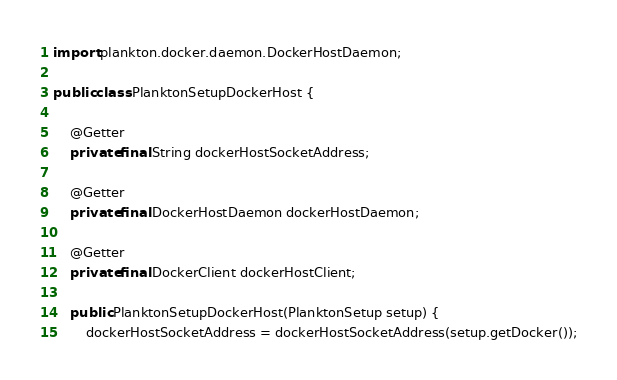Convert code to text. <code><loc_0><loc_0><loc_500><loc_500><_Java_>import plankton.docker.daemon.DockerHostDaemon;

public class PlanktonSetupDockerHost {

    @Getter
    private final String dockerHostSocketAddress;

    @Getter
    private final DockerHostDaemon dockerHostDaemon;

    @Getter
    private final DockerClient dockerHostClient;

    public PlanktonSetupDockerHost(PlanktonSetup setup) {
        dockerHostSocketAddress = dockerHostSocketAddress(setup.getDocker());</code> 